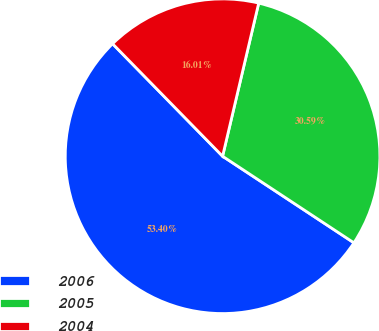Convert chart to OTSL. <chart><loc_0><loc_0><loc_500><loc_500><pie_chart><fcel>2006<fcel>2005<fcel>2004<nl><fcel>53.4%<fcel>30.59%<fcel>16.01%<nl></chart> 